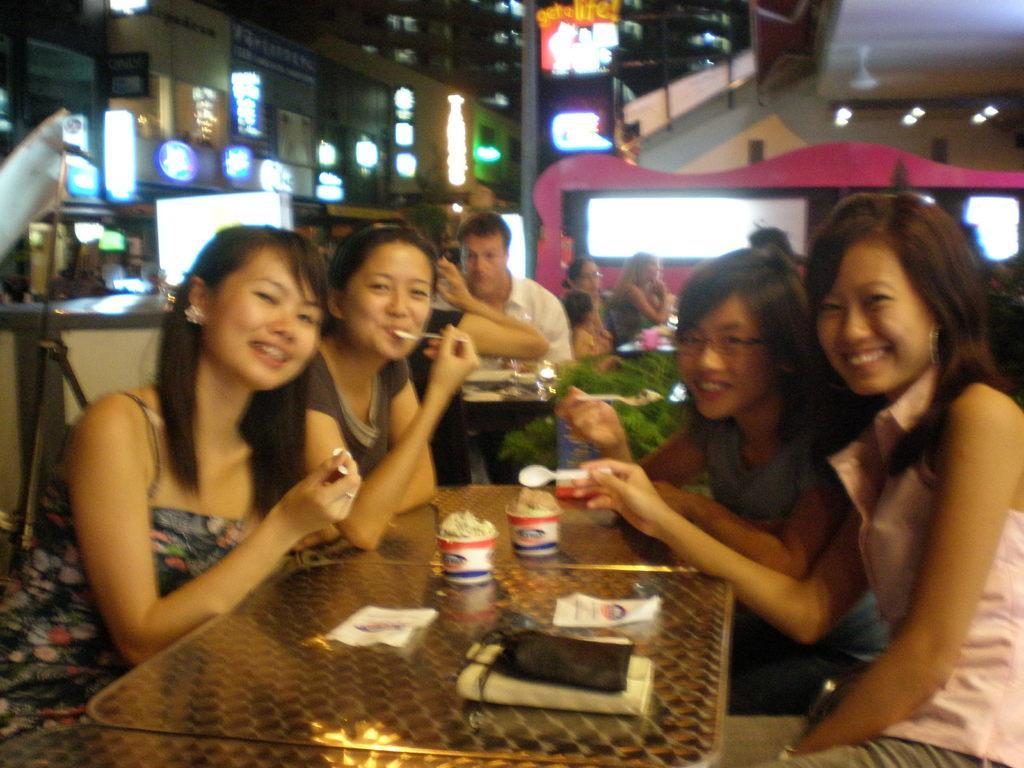Can you describe this image briefly? There are four girls sitting and smiling holding spoons. In front of them there is a table. On the table there are purse, two cups of ice cream, and papers. In the background many persons are sitting. Lights are over there. 